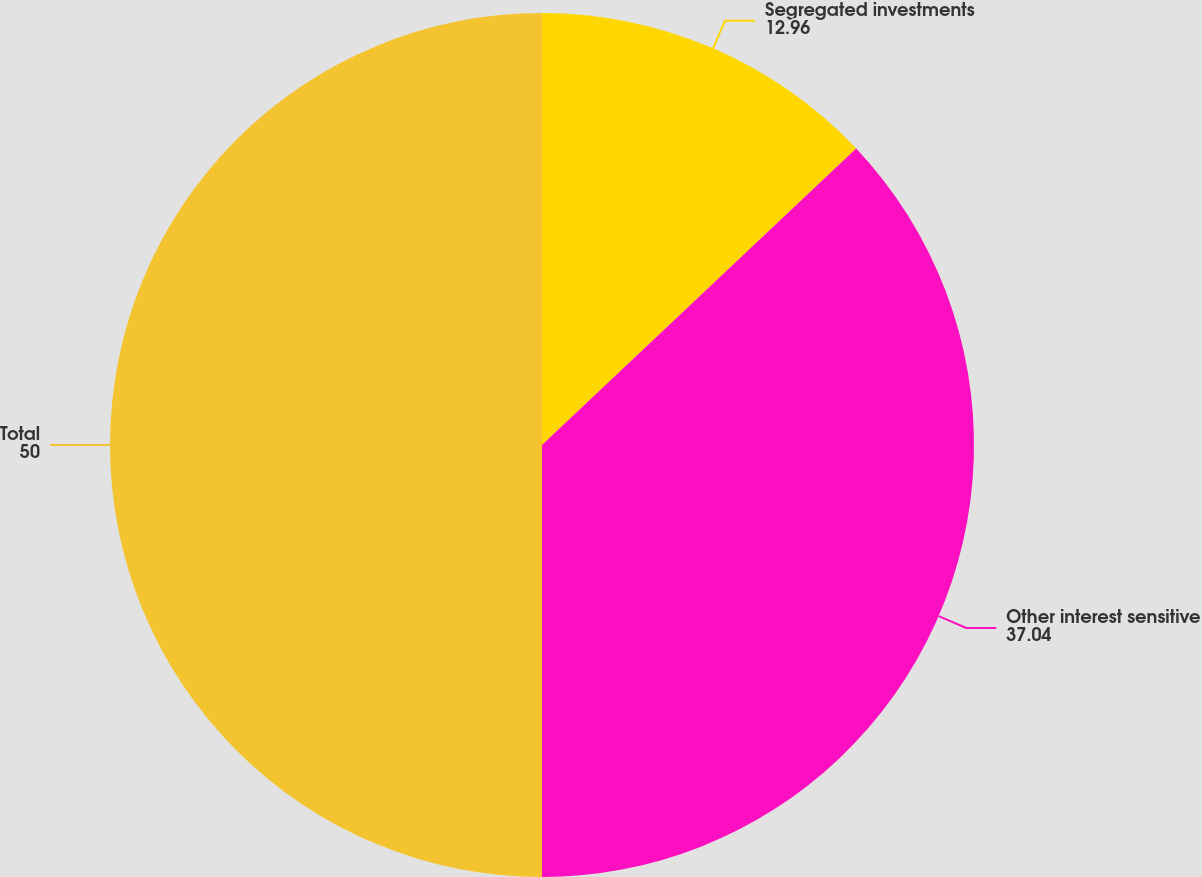Convert chart. <chart><loc_0><loc_0><loc_500><loc_500><pie_chart><fcel>Segregated investments<fcel>Other interest sensitive<fcel>Total<nl><fcel>12.96%<fcel>37.04%<fcel>50.0%<nl></chart> 